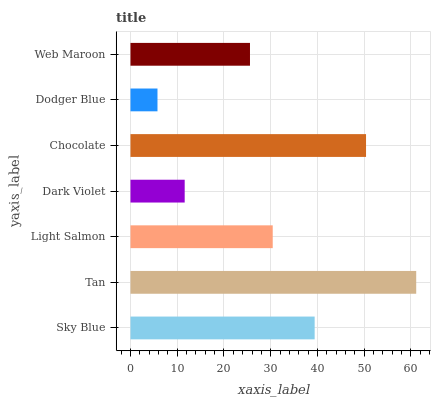Is Dodger Blue the minimum?
Answer yes or no. Yes. Is Tan the maximum?
Answer yes or no. Yes. Is Light Salmon the minimum?
Answer yes or no. No. Is Light Salmon the maximum?
Answer yes or no. No. Is Tan greater than Light Salmon?
Answer yes or no. Yes. Is Light Salmon less than Tan?
Answer yes or no. Yes. Is Light Salmon greater than Tan?
Answer yes or no. No. Is Tan less than Light Salmon?
Answer yes or no. No. Is Light Salmon the high median?
Answer yes or no. Yes. Is Light Salmon the low median?
Answer yes or no. Yes. Is Chocolate the high median?
Answer yes or no. No. Is Chocolate the low median?
Answer yes or no. No. 